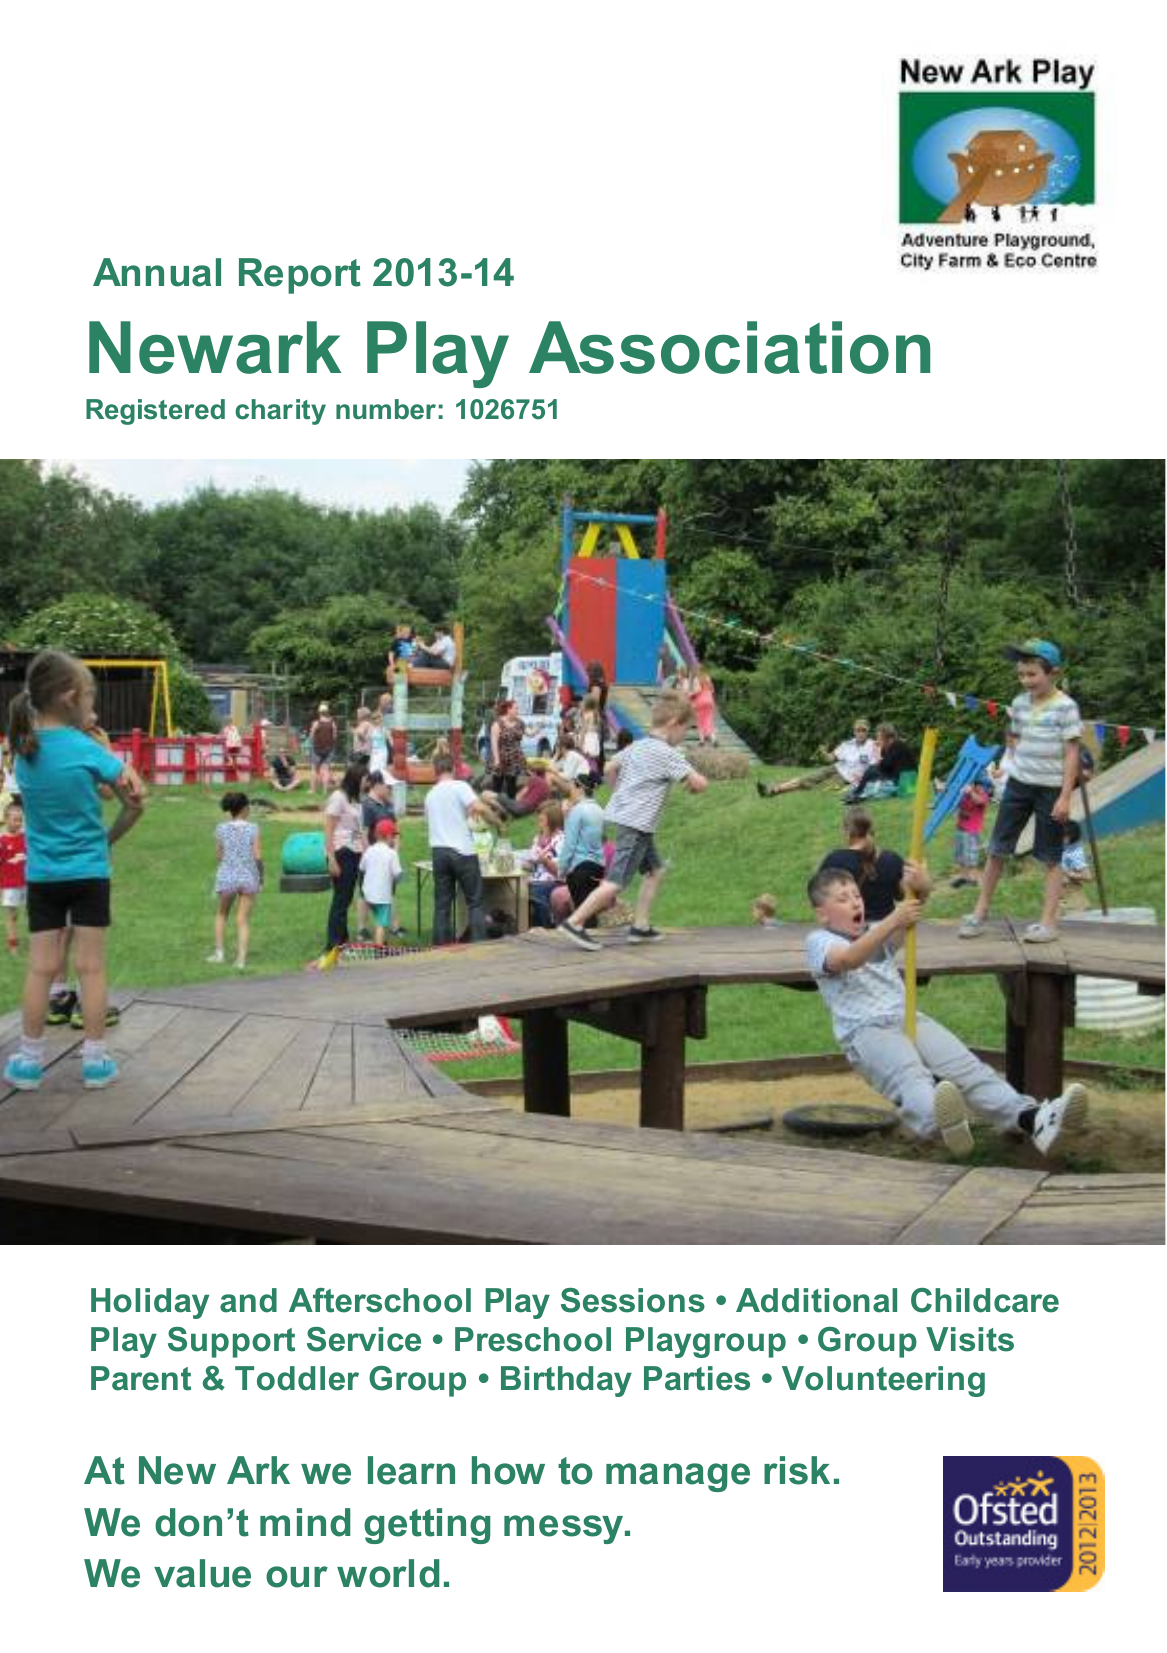What is the value for the address__postcode?
Answer the question using a single word or phrase. PE1 4PA 